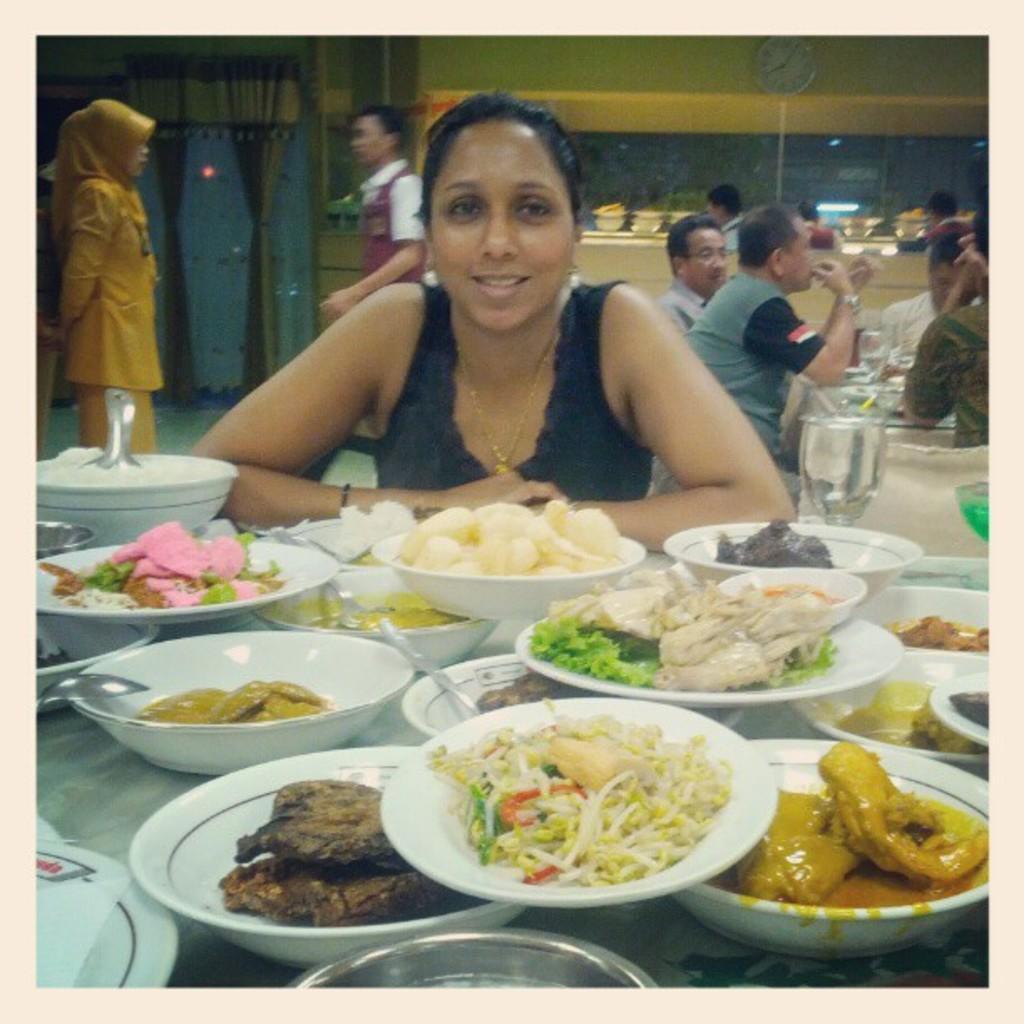Could you give a brief overview of what you see in this image? In this picture we can see a woman smiling and in front of her we can see bowls with food items in it, spoons and these all are placed on a surface and at the back of her we can see some people and two people are standing on the floor, clock, curtains and some objects. 